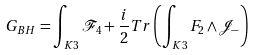<formula> <loc_0><loc_0><loc_500><loc_500>G _ { B H } = \int _ { K 3 } \mathcal { F } _ { 4 } + \frac { i } { 2 } T r \left ( \int _ { K 3 } F _ { 2 } \wedge \mathcal { J } _ { - } \right )</formula> 